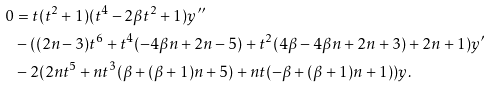Convert formula to latex. <formula><loc_0><loc_0><loc_500><loc_500>0 & = t ( t ^ { 2 } + 1 ) ( t ^ { 4 } - 2 \beta t ^ { 2 } + 1 ) y ^ { \prime \prime } \\ & - ( ( 2 n - 3 ) t ^ { 6 } + t ^ { 4 } ( - 4 \beta n + 2 n - 5 ) + t ^ { 2 } ( 4 \beta - 4 \beta n + 2 n + 3 ) + 2 n + 1 ) y ^ { \prime } \\ & - 2 ( 2 n t ^ { 5 } + n t ^ { 3 } ( \beta + ( \beta + 1 ) n + 5 ) + n t ( - \beta + ( \beta + 1 ) n + 1 ) ) y .</formula> 